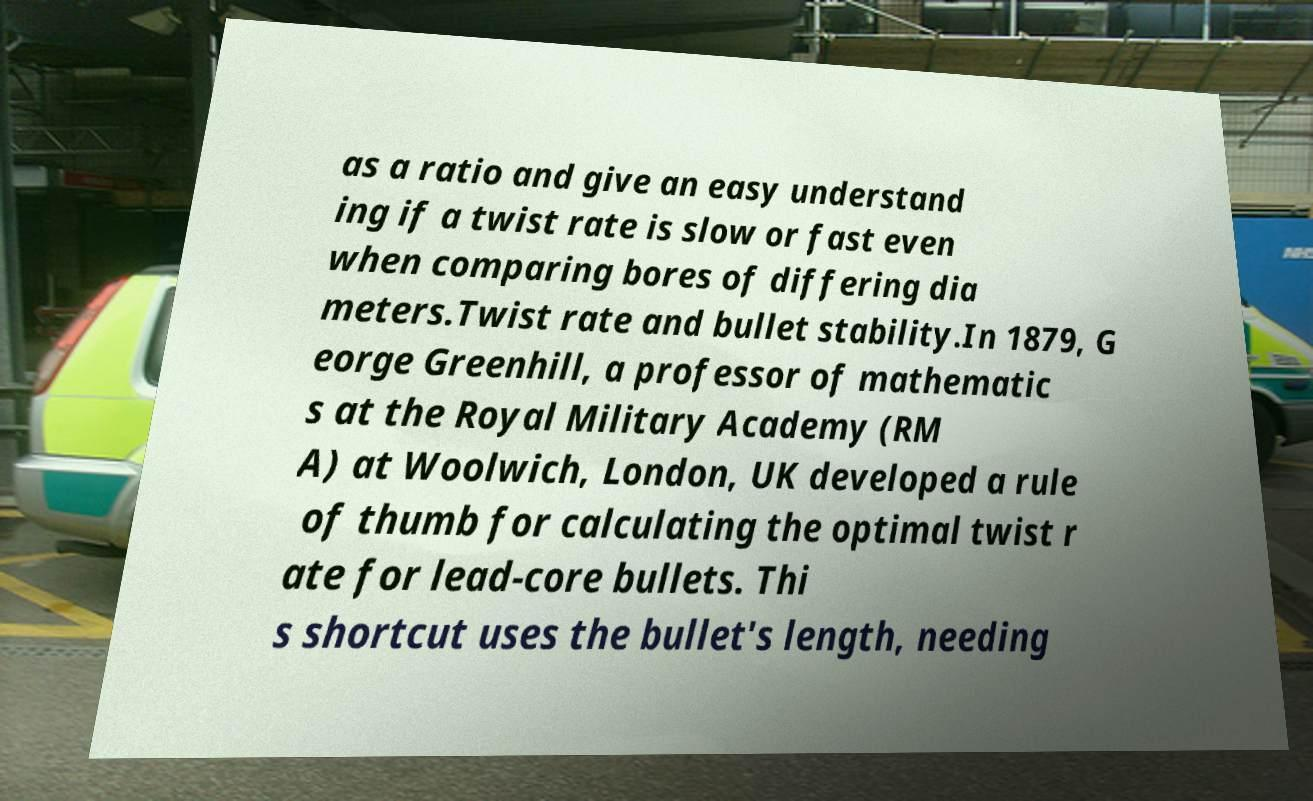Could you extract and type out the text from this image? as a ratio and give an easy understand ing if a twist rate is slow or fast even when comparing bores of differing dia meters.Twist rate and bullet stability.In 1879, G eorge Greenhill, a professor of mathematic s at the Royal Military Academy (RM A) at Woolwich, London, UK developed a rule of thumb for calculating the optimal twist r ate for lead-core bullets. Thi s shortcut uses the bullet's length, needing 